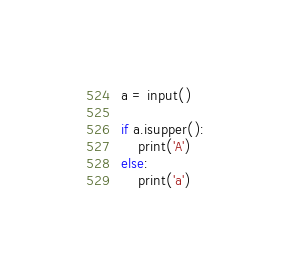<code> <loc_0><loc_0><loc_500><loc_500><_Python_>a = input()

if a.isupper():
	print('A')
else:
	print('a')</code> 